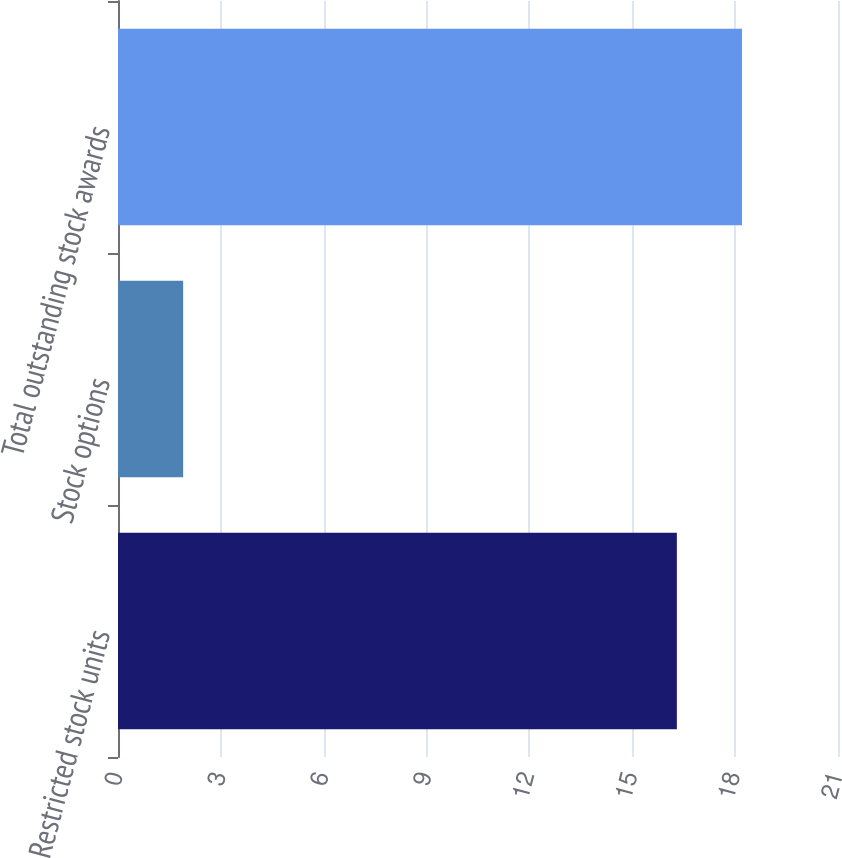Convert chart. <chart><loc_0><loc_0><loc_500><loc_500><bar_chart><fcel>Restricted stock units<fcel>Stock options<fcel>Total outstanding stock awards<nl><fcel>16.3<fcel>1.9<fcel>18.2<nl></chart> 